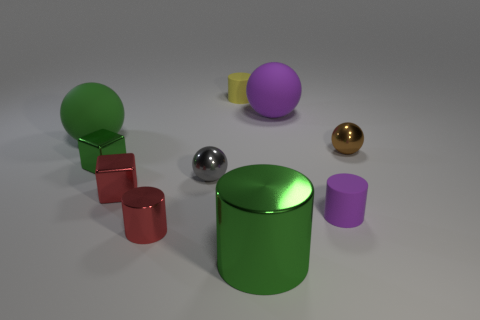Subtract all blocks. How many objects are left? 8 Add 5 small yellow cylinders. How many small yellow cylinders exist? 6 Subtract 0 gray blocks. How many objects are left? 10 Subtract all big green metallic cylinders. Subtract all large green shiny cylinders. How many objects are left? 8 Add 2 purple spheres. How many purple spheres are left? 3 